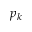<formula> <loc_0><loc_0><loc_500><loc_500>p _ { k }</formula> 